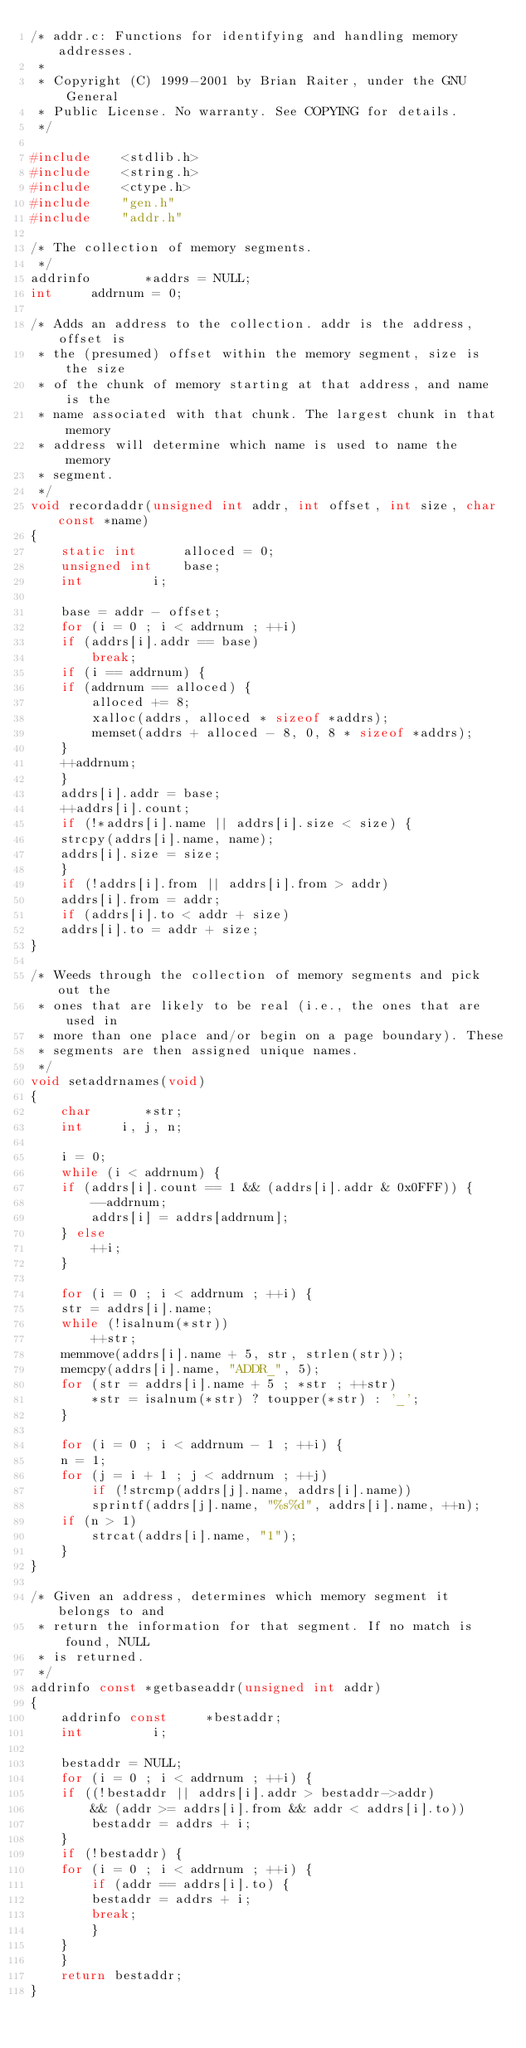Convert code to text. <code><loc_0><loc_0><loc_500><loc_500><_C_>/* addr.c: Functions for identifying and handling memory addresses.
 *
 * Copyright (C) 1999-2001 by Brian Raiter, under the GNU General
 * Public License. No warranty. See COPYING for details.
 */

#include	<stdlib.h>
#include	<string.h>
#include	<ctype.h>
#include	"gen.h"
#include	"addr.h"

/* The collection of memory segments.
 */
addrinfo       *addrs = NULL;
int		addrnum = 0;

/* Adds an address to the collection. addr is the address, offset is
 * the (presumed) offset within the memory segment, size is the size
 * of the chunk of memory starting at that address, and name is the
 * name associated with that chunk. The largest chunk in that memory
 * address will determine which name is used to name the memory
 * segment.
 */
void recordaddr(unsigned int addr, int offset, int size, char const *name)
{
    static int		alloced = 0;
    unsigned int	base;
    int			i;

    base = addr - offset;
    for (i = 0 ; i < addrnum ; ++i)
	if (addrs[i].addr == base)
	    break;
    if (i == addrnum) {
	if (addrnum == alloced) {
	    alloced += 8;
	    xalloc(addrs, alloced * sizeof *addrs);
	    memset(addrs + alloced - 8, 0, 8 * sizeof *addrs);
	}
	++addrnum;
    }
    addrs[i].addr = base;
    ++addrs[i].count;
    if (!*addrs[i].name || addrs[i].size < size) {
	strcpy(addrs[i].name, name);
	addrs[i].size = size;
    }
    if (!addrs[i].from || addrs[i].from > addr)
	addrs[i].from = addr;
    if (addrs[i].to < addr + size)
	addrs[i].to = addr + size;
}

/* Weeds through the collection of memory segments and pick out the
 * ones that are likely to be real (i.e., the ones that are used in
 * more than one place and/or begin on a page boundary). These
 * segments are then assigned unique names.
 */
void setaddrnames(void)
{
    char       *str;
    int		i, j, n;

    i = 0;
    while (i < addrnum) {
	if (addrs[i].count == 1 && (addrs[i].addr & 0x0FFF)) {
	    --addrnum;
	    addrs[i] = addrs[addrnum];
	} else
	    ++i;
    }

    for (i = 0 ; i < addrnum ; ++i) {
	str = addrs[i].name;
	while (!isalnum(*str))
	    ++str;
	memmove(addrs[i].name + 5, str, strlen(str));
	memcpy(addrs[i].name, "ADDR_", 5);
	for (str = addrs[i].name + 5 ; *str ; ++str)
	    *str = isalnum(*str) ? toupper(*str) : '_';
    }

    for (i = 0 ; i < addrnum - 1 ; ++i) {
	n = 1;
	for (j = i + 1 ; j < addrnum ; ++j)
	    if (!strcmp(addrs[j].name, addrs[i].name))
		sprintf(addrs[j].name, "%s%d", addrs[i].name, ++n);
	if (n > 1)
	    strcat(addrs[i].name, "1");
    }
}

/* Given an address, determines which memory segment it belongs to and
 * return the information for that segment. If no match is found, NULL
 * is returned.
 */
addrinfo const *getbaseaddr(unsigned int addr)
{
    addrinfo const     *bestaddr;
    int			i;

    bestaddr = NULL;
    for (i = 0 ; i < addrnum ; ++i) {
	if ((!bestaddr || addrs[i].addr > bestaddr->addr)
		&& (addr >= addrs[i].from && addr < addrs[i].to))
	    bestaddr = addrs + i;
    }
    if (!bestaddr) {
	for (i = 0 ; i < addrnum ; ++i) {
	    if (addr == addrs[i].to) {
		bestaddr = addrs + i;
		break;
	    }
	}
    }
    return bestaddr;
}
</code> 